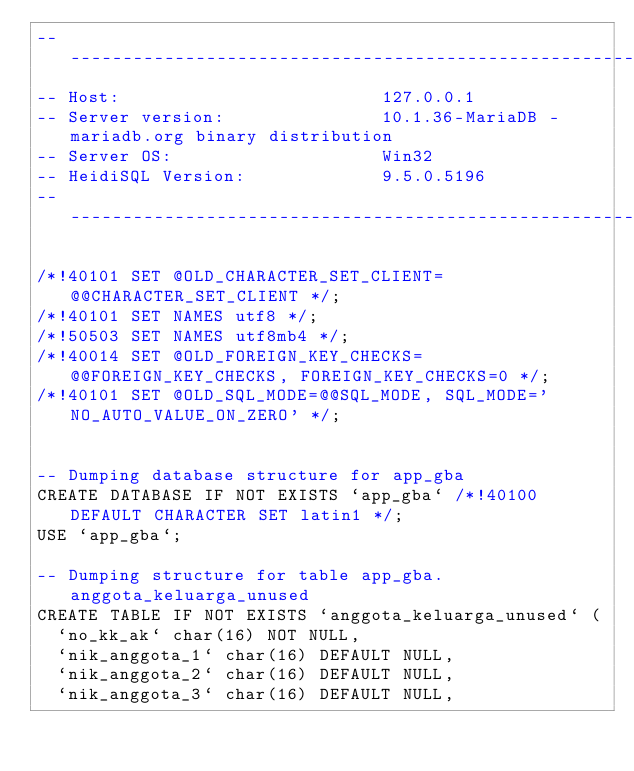<code> <loc_0><loc_0><loc_500><loc_500><_SQL_>-- --------------------------------------------------------
-- Host:                         127.0.0.1
-- Server version:               10.1.36-MariaDB - mariadb.org binary distribution
-- Server OS:                    Win32
-- HeidiSQL Version:             9.5.0.5196
-- --------------------------------------------------------

/*!40101 SET @OLD_CHARACTER_SET_CLIENT=@@CHARACTER_SET_CLIENT */;
/*!40101 SET NAMES utf8 */;
/*!50503 SET NAMES utf8mb4 */;
/*!40014 SET @OLD_FOREIGN_KEY_CHECKS=@@FOREIGN_KEY_CHECKS, FOREIGN_KEY_CHECKS=0 */;
/*!40101 SET @OLD_SQL_MODE=@@SQL_MODE, SQL_MODE='NO_AUTO_VALUE_ON_ZERO' */;


-- Dumping database structure for app_gba
CREATE DATABASE IF NOT EXISTS `app_gba` /*!40100 DEFAULT CHARACTER SET latin1 */;
USE `app_gba`;

-- Dumping structure for table app_gba.anggota_keluarga_unused
CREATE TABLE IF NOT EXISTS `anggota_keluarga_unused` (
  `no_kk_ak` char(16) NOT NULL,
  `nik_anggota_1` char(16) DEFAULT NULL,
  `nik_anggota_2` char(16) DEFAULT NULL,
  `nik_anggota_3` char(16) DEFAULT NULL,</code> 